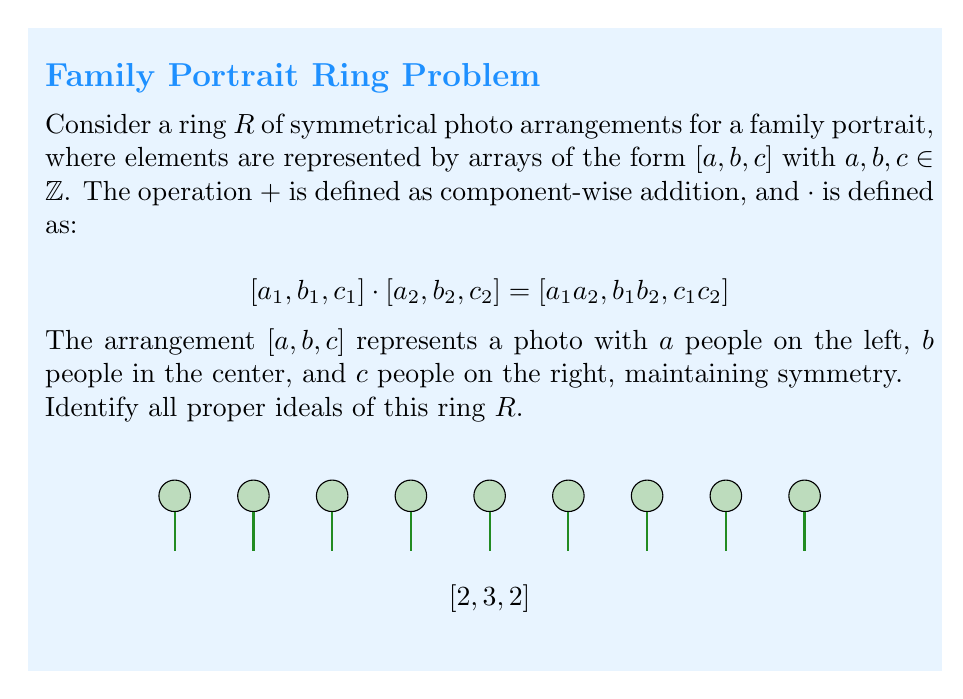Solve this math problem. Let's approach this step-by-step:

1) First, recall that an ideal $I$ of a ring $R$ is a subset of $R$ that is closed under addition and multiplication by any element of $R$.

2) In this ring, the zero element is $[0, 0, 0]$, which must be in every ideal.

3) Let's consider the possible ideals:

   a) The trivial ideal $\{[0, 0, 0]\}$ is always a proper ideal.

   b) Single-component ideals:
      - $I_1 = \{[a, 0, 0] | a \in \mathbb{Z}\}$
      - $I_2 = \{[0, b, 0] | b \in \mathbb{Z}\}$
      - $I_3 = \{[0, 0, c] | c \in \mathbb{Z}\}$
      These are proper ideals because they're closed under addition and multiplication by any element of $R$.

   c) Two-component ideals:
      - $I_{12} = \{[a, b, 0] | a, b \in \mathbb{Z}\}$
      - $I_{13} = \{[a, 0, c] | a, c \in \mathbb{Z}\}$
      - $I_{23} = \{[0, b, c] | b, c \in \mathbb{Z}\}$
      These are also proper ideals.

4) The ideal $\{[a, b, c] | a, b, c \in \mathbb{Z}\}$ is not proper as it equals the entire ring $R$.

5) There are no other proper ideals because any ideal containing elements with all three components non-zero would generate the entire ring under multiplication.

Therefore, we have identified all proper ideals of the ring $R$.
Answer: $\{[0,0,0]\}$, $\{[a,0,0]\}$, $\{[0,b,0]\}$, $\{[0,0,c]\}$, $\{[a,b,0]\}$, $\{[a,0,c]\}$, $\{[0,b,c]\}$ where $a,b,c \in \mathbb{Z}$ 